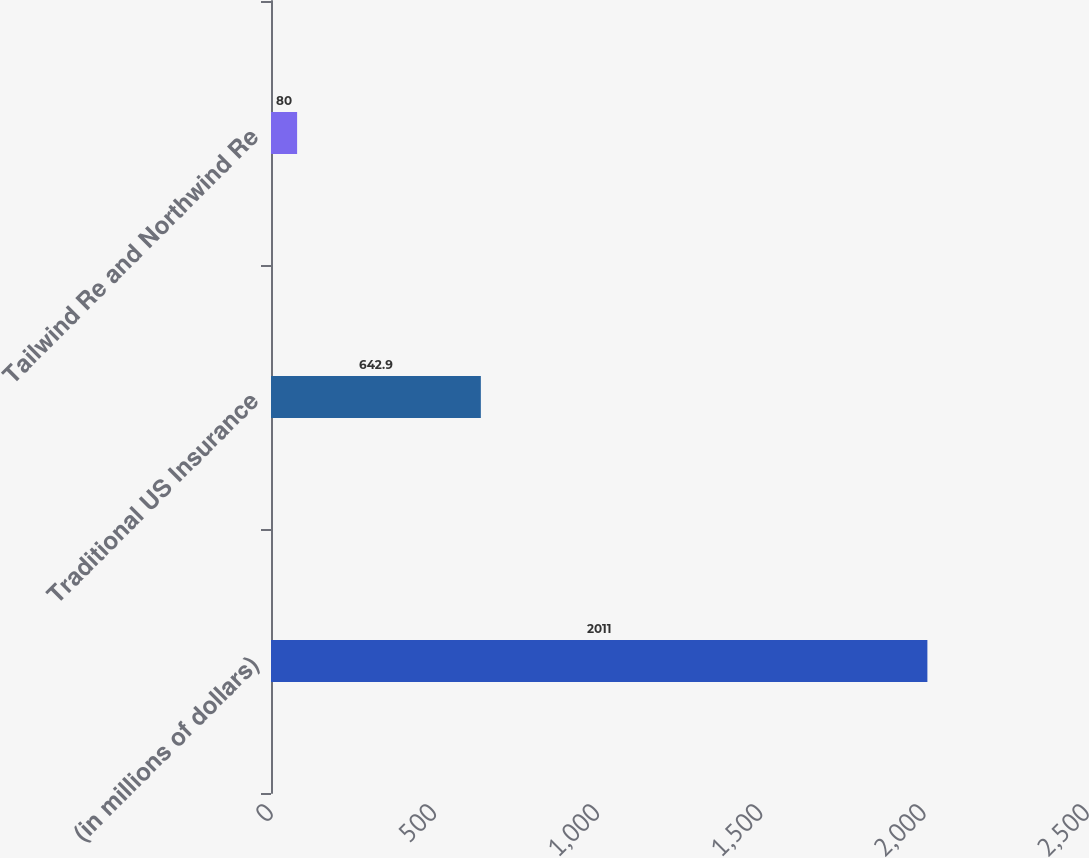<chart> <loc_0><loc_0><loc_500><loc_500><bar_chart><fcel>(in millions of dollars)<fcel>Traditional US Insurance<fcel>Tailwind Re and Northwind Re<nl><fcel>2011<fcel>642.9<fcel>80<nl></chart> 